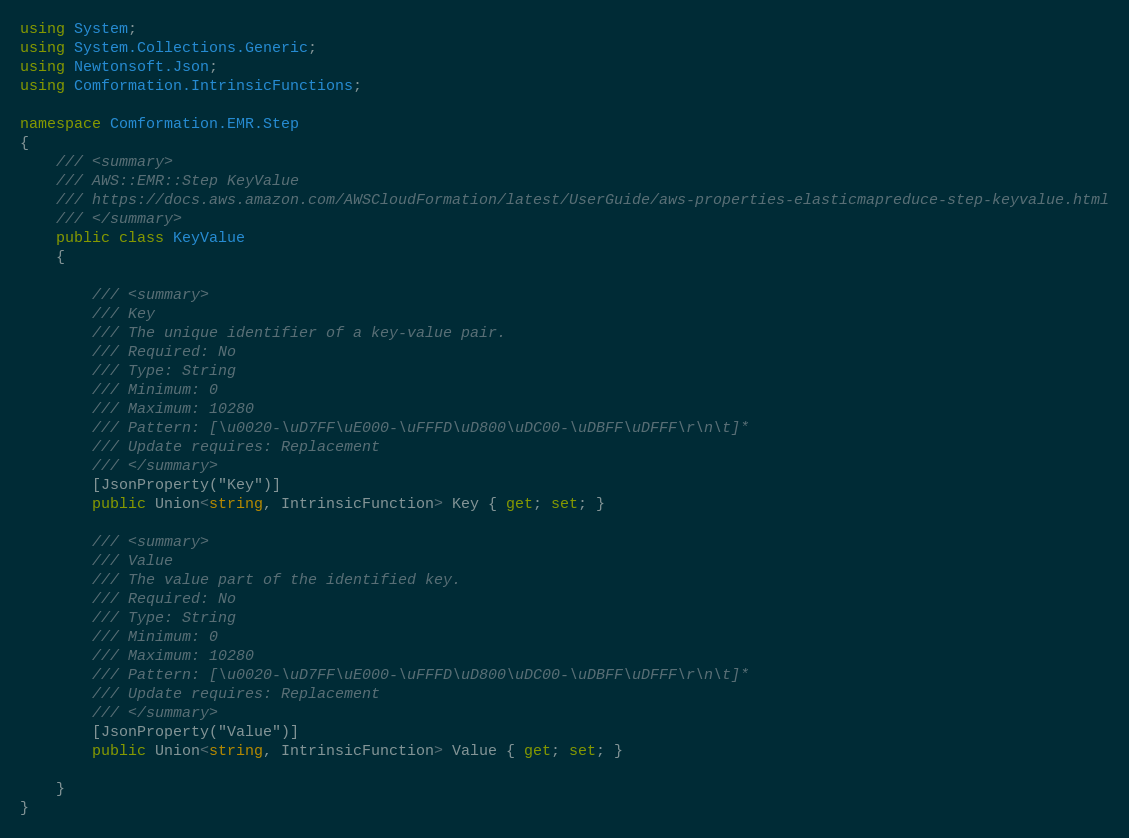<code> <loc_0><loc_0><loc_500><loc_500><_C#_>using System;
using System.Collections.Generic;
using Newtonsoft.Json;
using Comformation.IntrinsicFunctions;

namespace Comformation.EMR.Step
{
    /// <summary>
    /// AWS::EMR::Step KeyValue
    /// https://docs.aws.amazon.com/AWSCloudFormation/latest/UserGuide/aws-properties-elasticmapreduce-step-keyvalue.html
    /// </summary>
    public class KeyValue
    {

        /// <summary>
        /// Key
        /// The unique identifier of a key-value pair.
        /// Required: No
        /// Type: String
        /// Minimum: 0
        /// Maximum: 10280
        /// Pattern: [\u0020-\uD7FF\uE000-\uFFFD\uD800\uDC00-\uDBFF\uDFFF\r\n\t]*
        /// Update requires: Replacement
        /// </summary>
        [JsonProperty("Key")]
        public Union<string, IntrinsicFunction> Key { get; set; }

        /// <summary>
        /// Value
        /// The value part of the identified key.
        /// Required: No
        /// Type: String
        /// Minimum: 0
        /// Maximum: 10280
        /// Pattern: [\u0020-\uD7FF\uE000-\uFFFD\uD800\uDC00-\uDBFF\uDFFF\r\n\t]*
        /// Update requires: Replacement
        /// </summary>
        [JsonProperty("Value")]
        public Union<string, IntrinsicFunction> Value { get; set; }

    }
}
</code> 